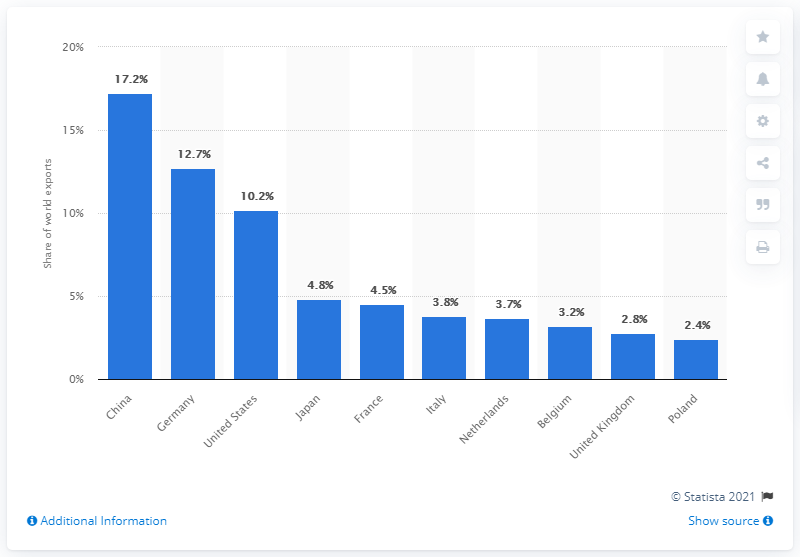Point out several critical features in this image. China was the largest exporter of personal protective products in 2019. 